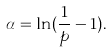Convert formula to latex. <formula><loc_0><loc_0><loc_500><loc_500>\alpha = \ln ( \frac { 1 } { p } - 1 ) .</formula> 